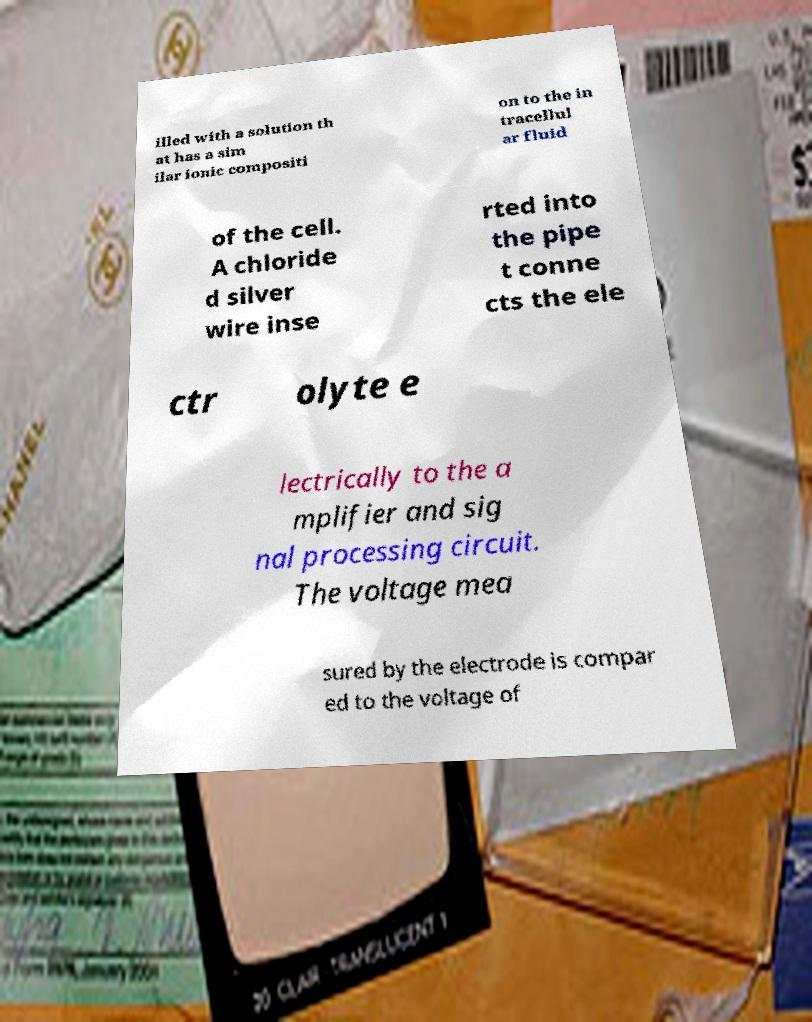Please read and relay the text visible in this image. What does it say? illed with a solution th at has a sim ilar ionic compositi on to the in tracellul ar fluid of the cell. A chloride d silver wire inse rted into the pipe t conne cts the ele ctr olyte e lectrically to the a mplifier and sig nal processing circuit. The voltage mea sured by the electrode is compar ed to the voltage of 